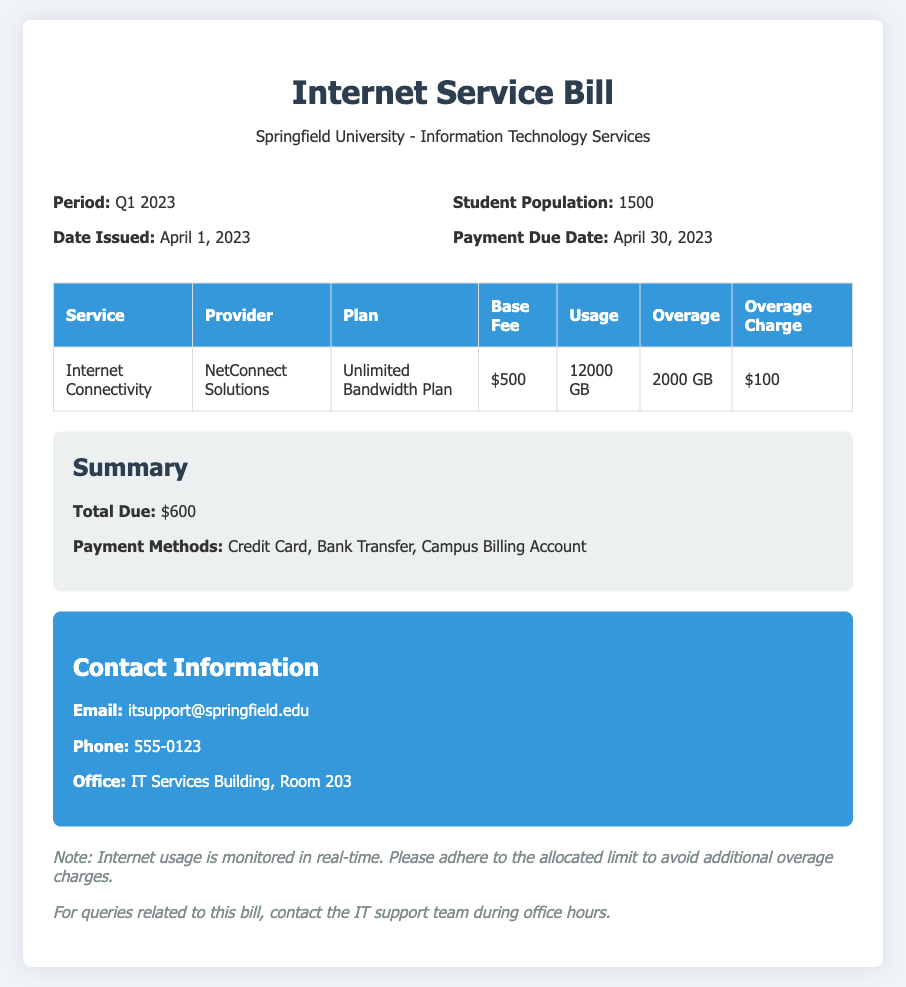What is the period of the bill? The period of the bill is stated in the document as Q1 2023.
Answer: Q1 2023 Who is the internet service provider? The document lists NetConnect Solutions as the provider of internet services.
Answer: NetConnect Solutions What is the base fee for internet connectivity? The base fee for internet connectivity is included in the bill as $500.
Answer: $500 How much bandwidth was used? The document specifies that 12000 GB of bandwidth was used during the period.
Answer: 12000 GB What is the payment due date? The due date for payment is mentioned as April 30, 2023, in the document.
Answer: April 30, 2023 What is the total amount due? The total due amount is clearly indicated in the summary of the document as $600.
Answer: $600 What is the overage charge amount? The document specifies the overage charge as $100 associated with the additional usage.
Answer: $100 How much overage was incurred? The bill states that an overage of 2000 GB was incurred during the period.
Answer: 2000 GB What payment methods are available? The payment methods are listed in the summary as Credit Card, Bank Transfer, Campus Billing Account.
Answer: Credit Card, Bank Transfer, Campus Billing Account 